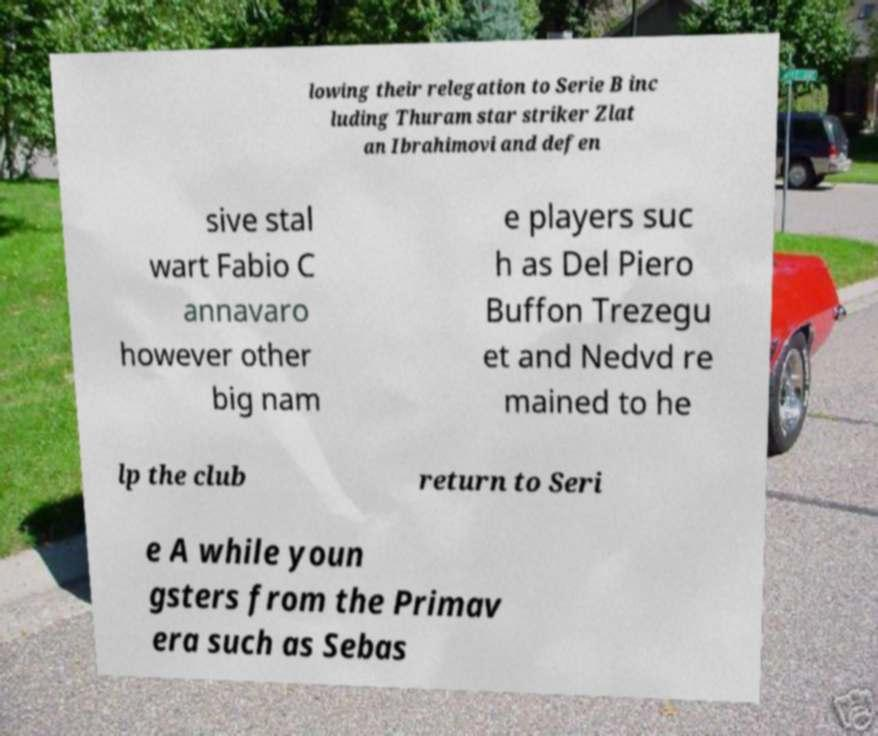What messages or text are displayed in this image? I need them in a readable, typed format. lowing their relegation to Serie B inc luding Thuram star striker Zlat an Ibrahimovi and defen sive stal wart Fabio C annavaro however other big nam e players suc h as Del Piero Buffon Trezegu et and Nedvd re mained to he lp the club return to Seri e A while youn gsters from the Primav era such as Sebas 